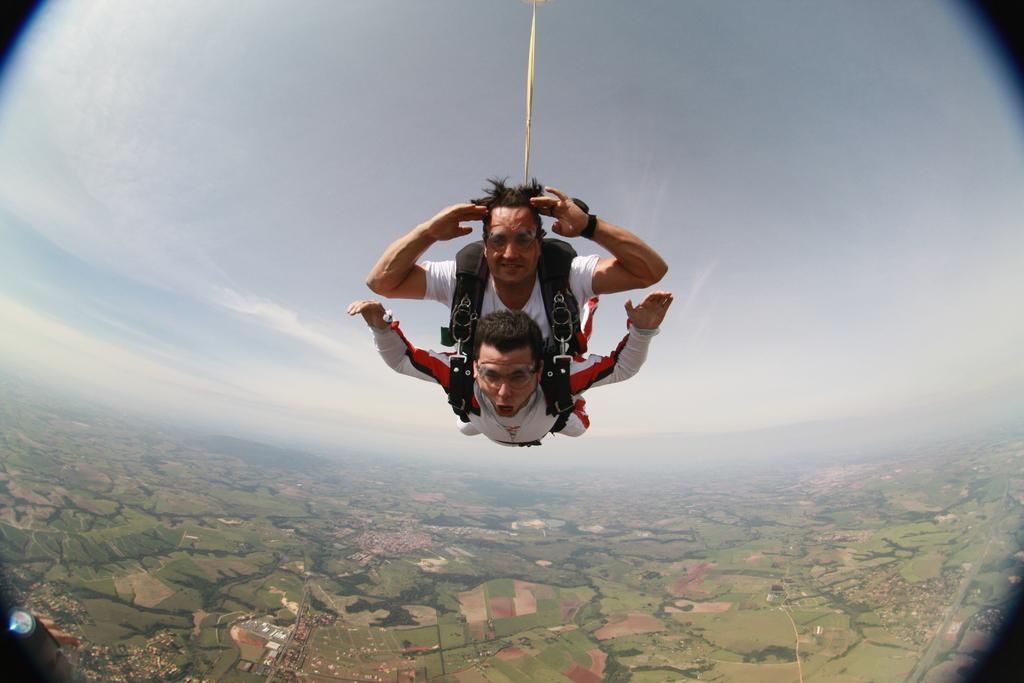What is located at the bottom left side of the image? There is an object at the bottom left side of the image. What are the two persons in the image doing? The two persons are skydiving in the center of the image. What can be seen in the background of the image? The sky and land are visible in the background of the image. What type of tank can be seen in the image? There is no tank present in the image. How many legs does the person on the left have while skydiving? The image does not show the legs of the persons skydiving, so it cannot be determined how many legs they have. 